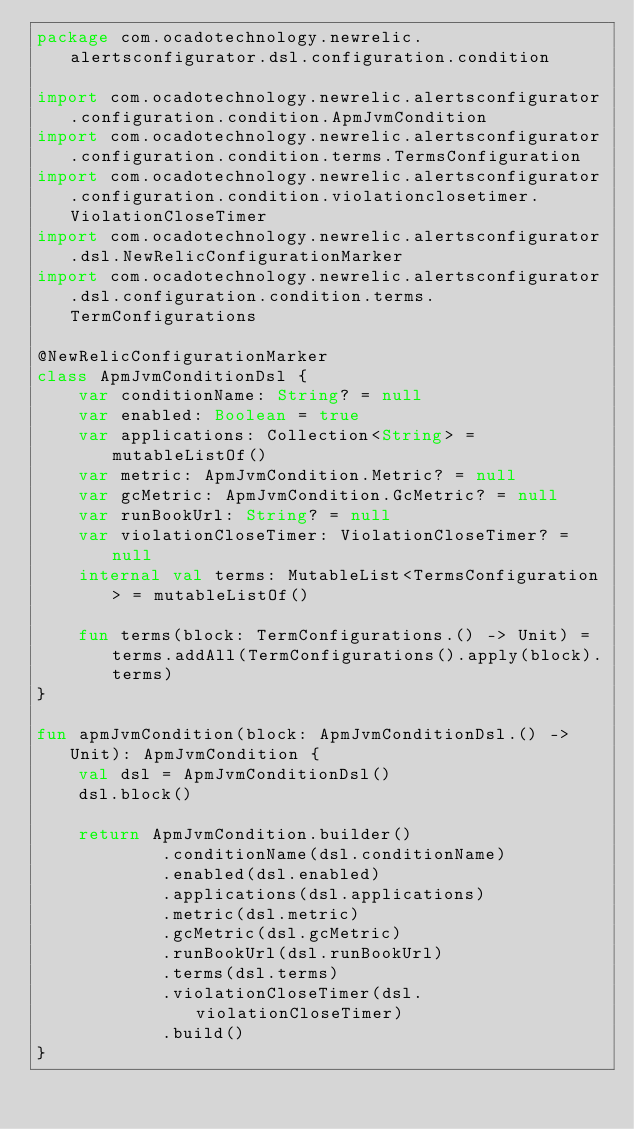Convert code to text. <code><loc_0><loc_0><loc_500><loc_500><_Kotlin_>package com.ocadotechnology.newrelic.alertsconfigurator.dsl.configuration.condition

import com.ocadotechnology.newrelic.alertsconfigurator.configuration.condition.ApmJvmCondition
import com.ocadotechnology.newrelic.alertsconfigurator.configuration.condition.terms.TermsConfiguration
import com.ocadotechnology.newrelic.alertsconfigurator.configuration.condition.violationclosetimer.ViolationCloseTimer
import com.ocadotechnology.newrelic.alertsconfigurator.dsl.NewRelicConfigurationMarker
import com.ocadotechnology.newrelic.alertsconfigurator.dsl.configuration.condition.terms.TermConfigurations

@NewRelicConfigurationMarker
class ApmJvmConditionDsl {
    var conditionName: String? = null
    var enabled: Boolean = true
    var applications: Collection<String> = mutableListOf()
    var metric: ApmJvmCondition.Metric? = null
    var gcMetric: ApmJvmCondition.GcMetric? = null
    var runBookUrl: String? = null
    var violationCloseTimer: ViolationCloseTimer? = null
    internal val terms: MutableList<TermsConfiguration> = mutableListOf()

    fun terms(block: TermConfigurations.() -> Unit) = terms.addAll(TermConfigurations().apply(block).terms)
}

fun apmJvmCondition(block: ApmJvmConditionDsl.() -> Unit): ApmJvmCondition {
    val dsl = ApmJvmConditionDsl()
    dsl.block()

    return ApmJvmCondition.builder()
            .conditionName(dsl.conditionName)
            .enabled(dsl.enabled)
            .applications(dsl.applications)
            .metric(dsl.metric)
            .gcMetric(dsl.gcMetric)
            .runBookUrl(dsl.runBookUrl)
            .terms(dsl.terms)
            .violationCloseTimer(dsl.violationCloseTimer)
            .build()
}</code> 